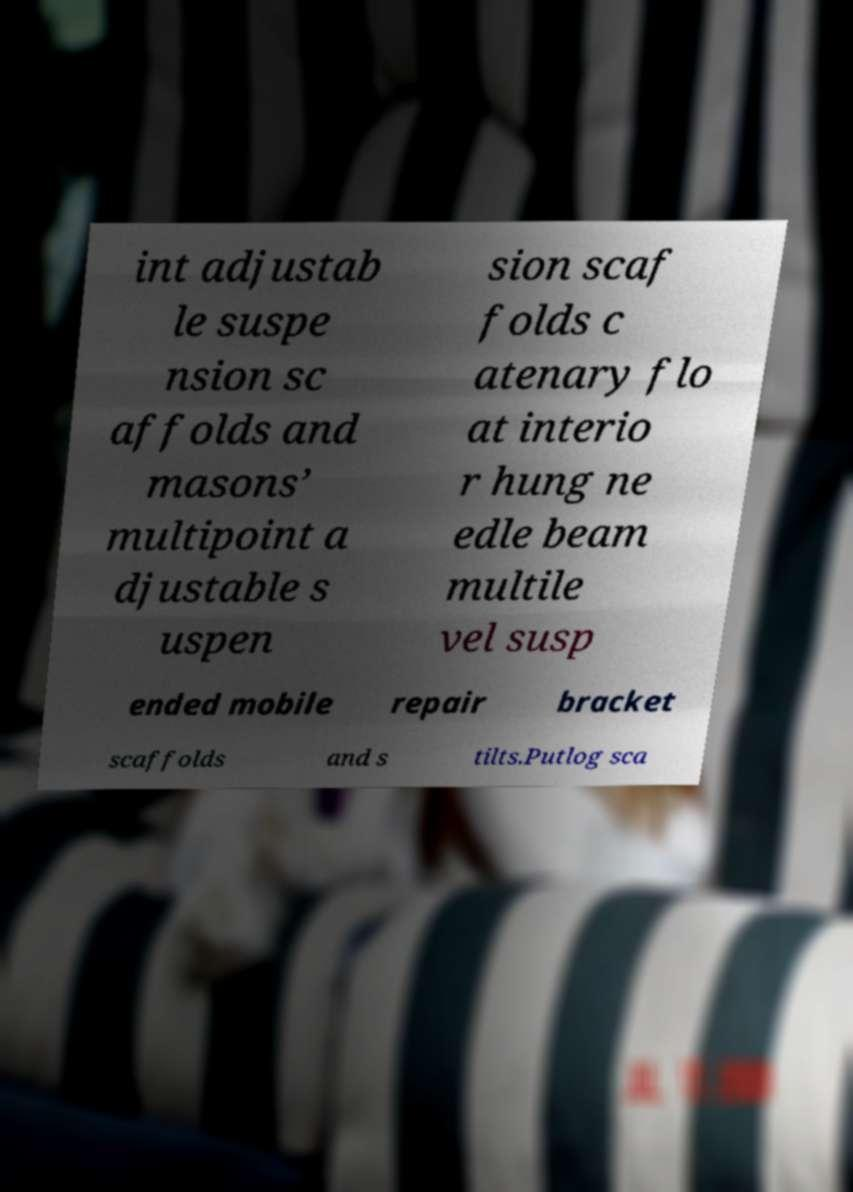I need the written content from this picture converted into text. Can you do that? int adjustab le suspe nsion sc affolds and masons’ multipoint a djustable s uspen sion scaf folds c atenary flo at interio r hung ne edle beam multile vel susp ended mobile repair bracket scaffolds and s tilts.Putlog sca 